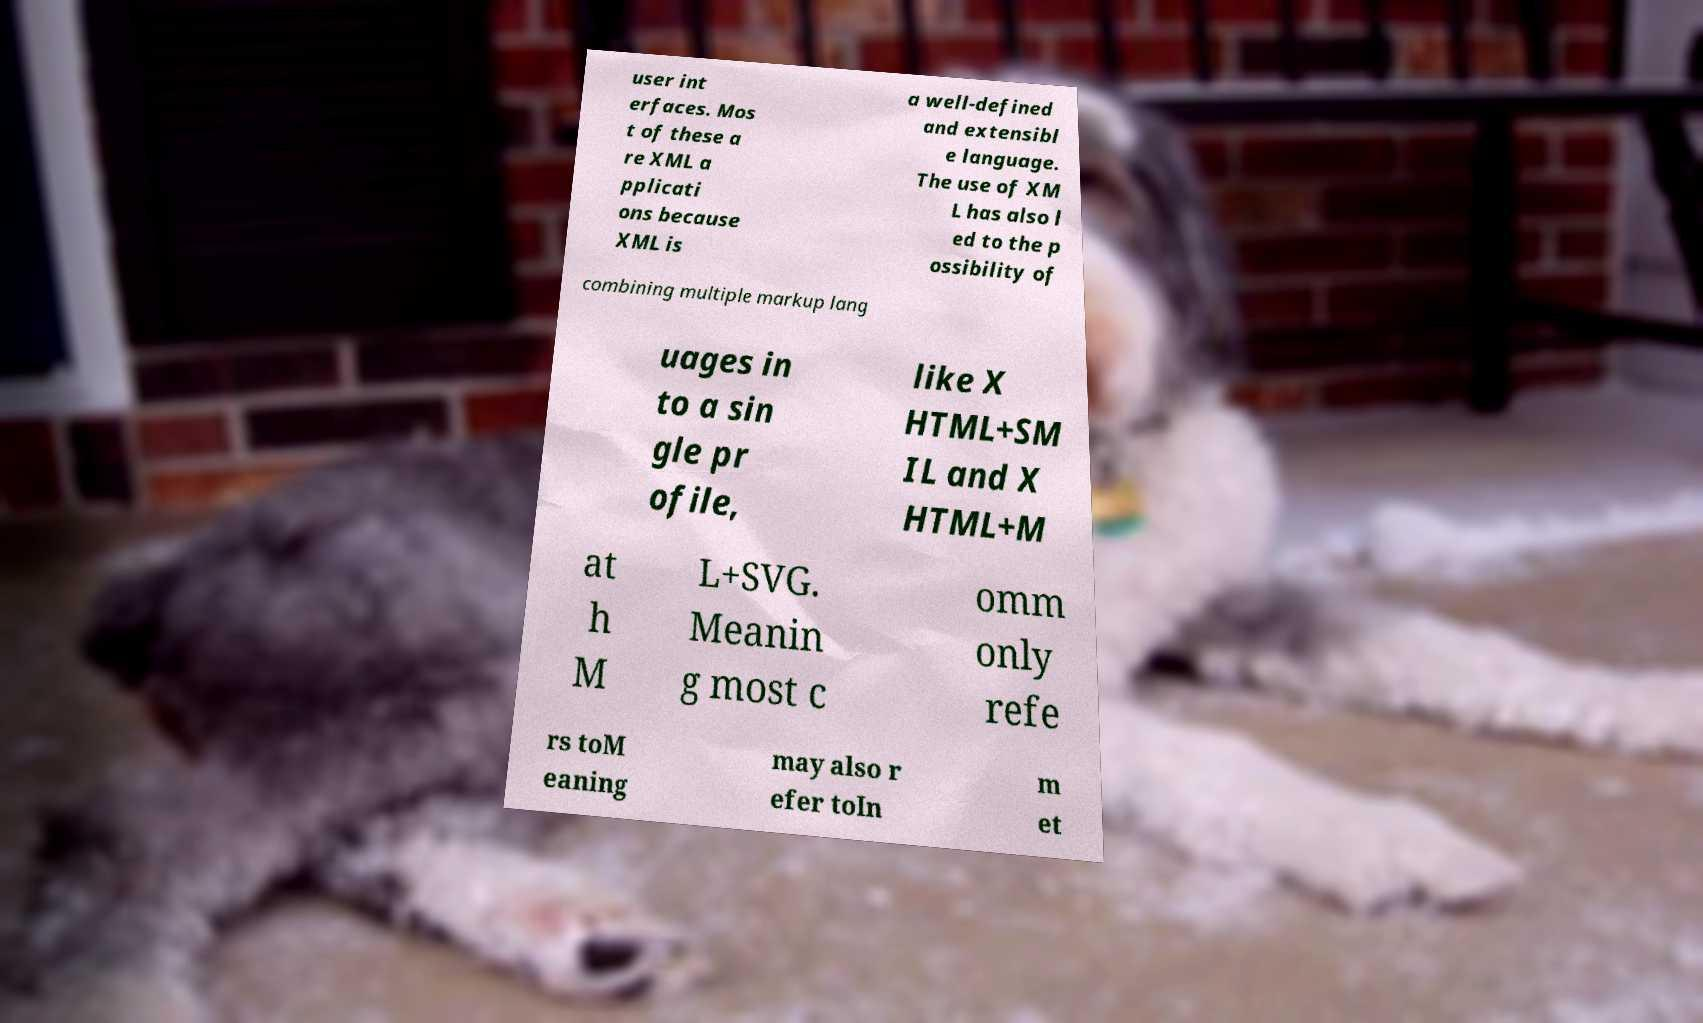There's text embedded in this image that I need extracted. Can you transcribe it verbatim? user int erfaces. Mos t of these a re XML a pplicati ons because XML is a well-defined and extensibl e language. The use of XM L has also l ed to the p ossibility of combining multiple markup lang uages in to a sin gle pr ofile, like X HTML+SM IL and X HTML+M at h M L+SVG. Meanin g most c omm only refe rs toM eaning may also r efer toIn m et 